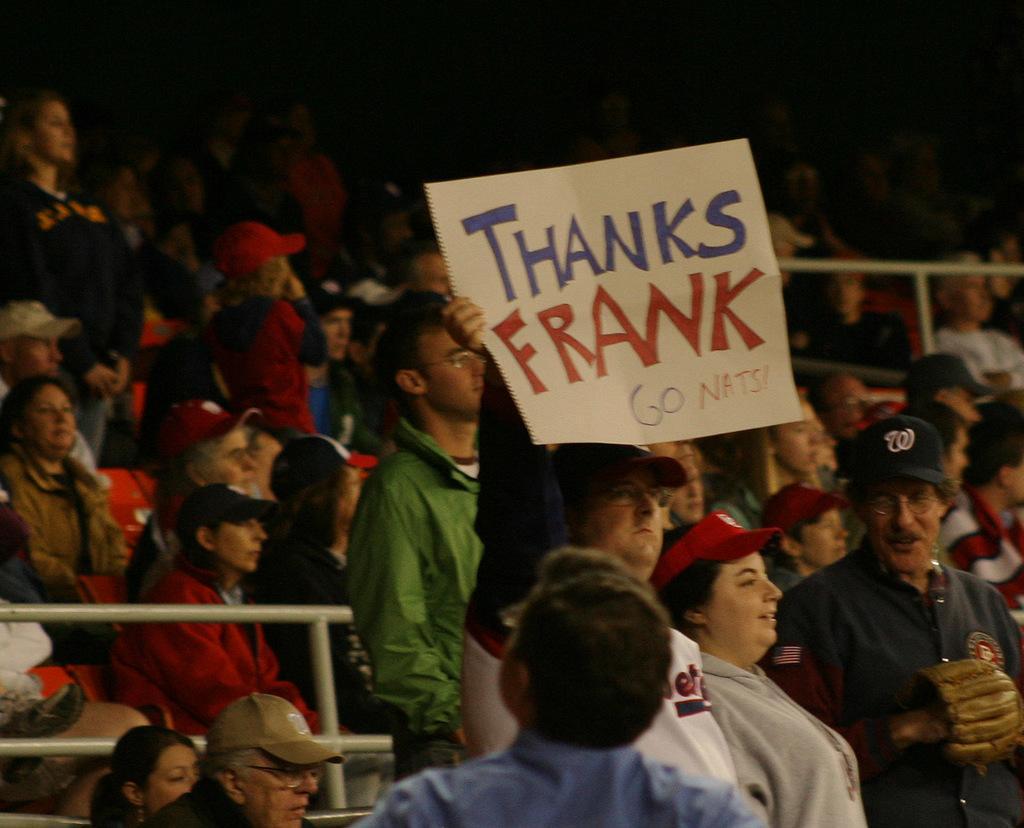Please provide a concise description of this image. In the image there are many people standing and sitting, the man in the middle holding a paper with a note on it, it seems to be they all looking at a game. 